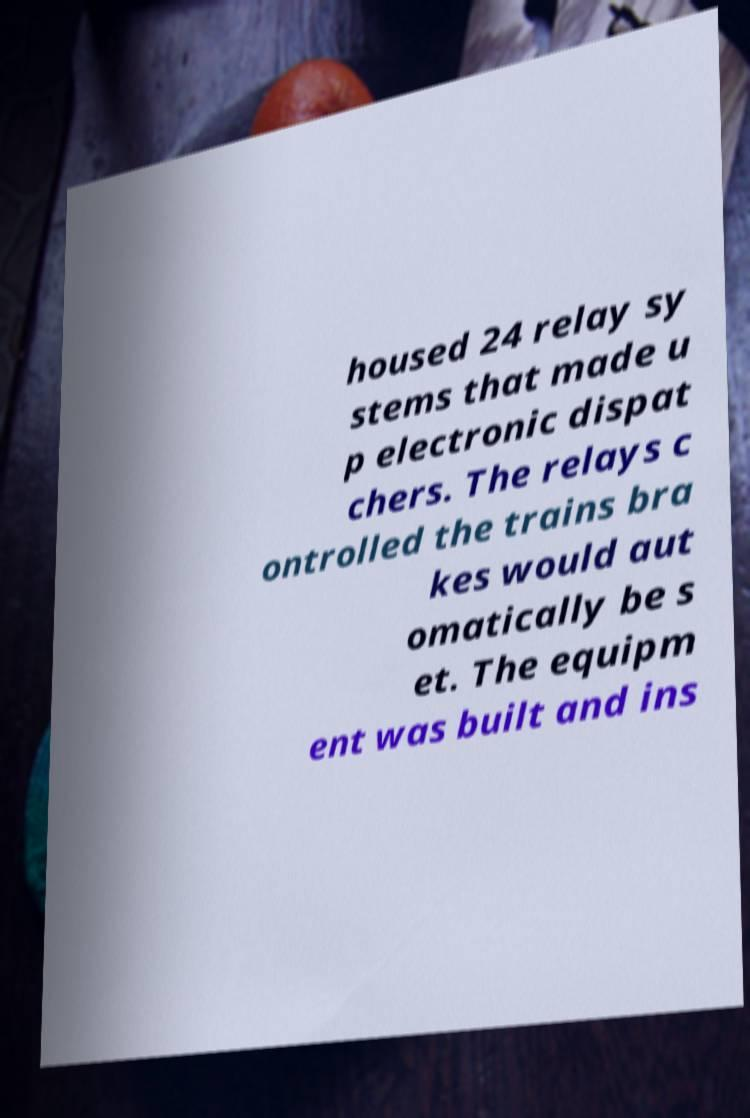There's text embedded in this image that I need extracted. Can you transcribe it verbatim? housed 24 relay sy stems that made u p electronic dispat chers. The relays c ontrolled the trains bra kes would aut omatically be s et. The equipm ent was built and ins 